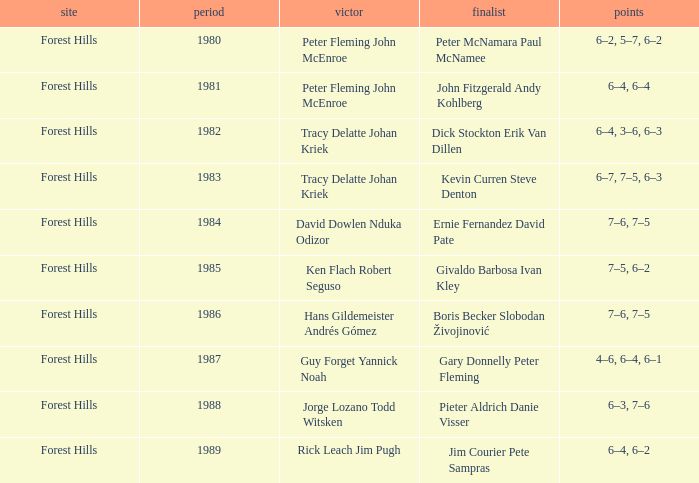Who were the champions in 1988? Jorge Lozano Todd Witsken. 